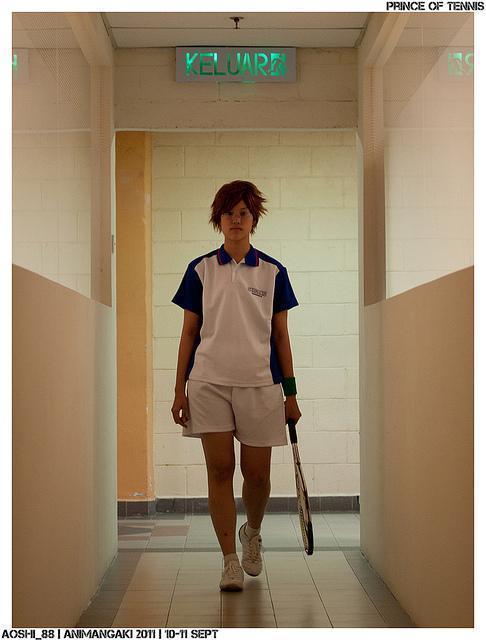How many cats are on the sofa?
Give a very brief answer. 0. 